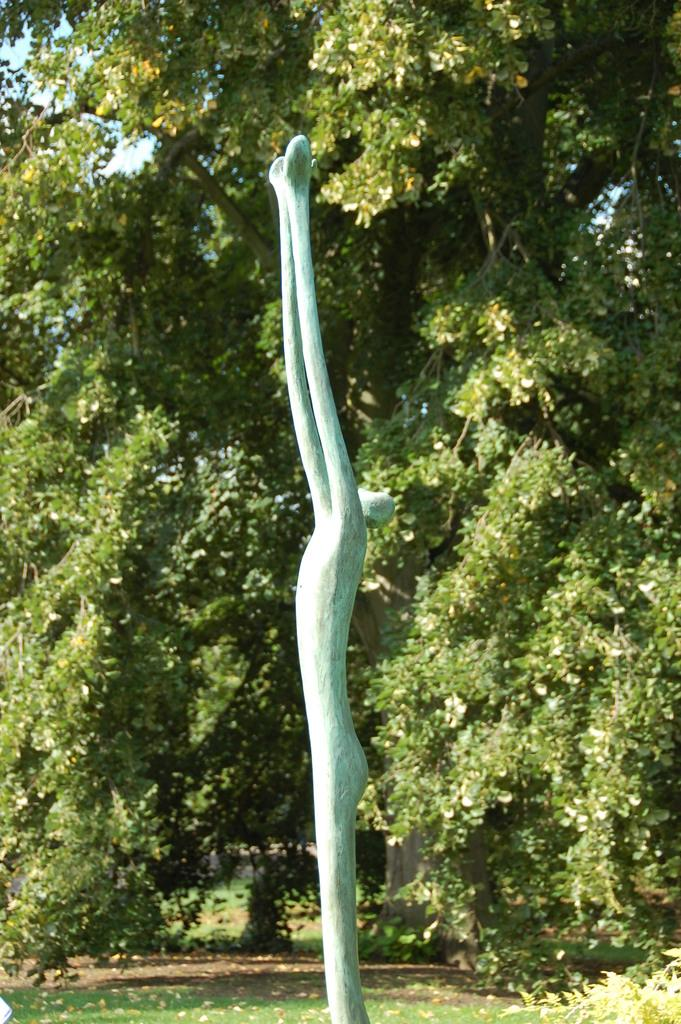What type of vegetation is present in the image? There are trees in the image. What type of ground cover is present in the image? There is grass in the image. What can be observed about the lighting in the image? There are shadows in the image. What color is the object or area that stands out in the image? There is a blue object or area in the image. What type of reaction does the grandfather have when he sees the lace in the image? There is no grandfather or lace present in the image, so it is not possible to answer that question. 